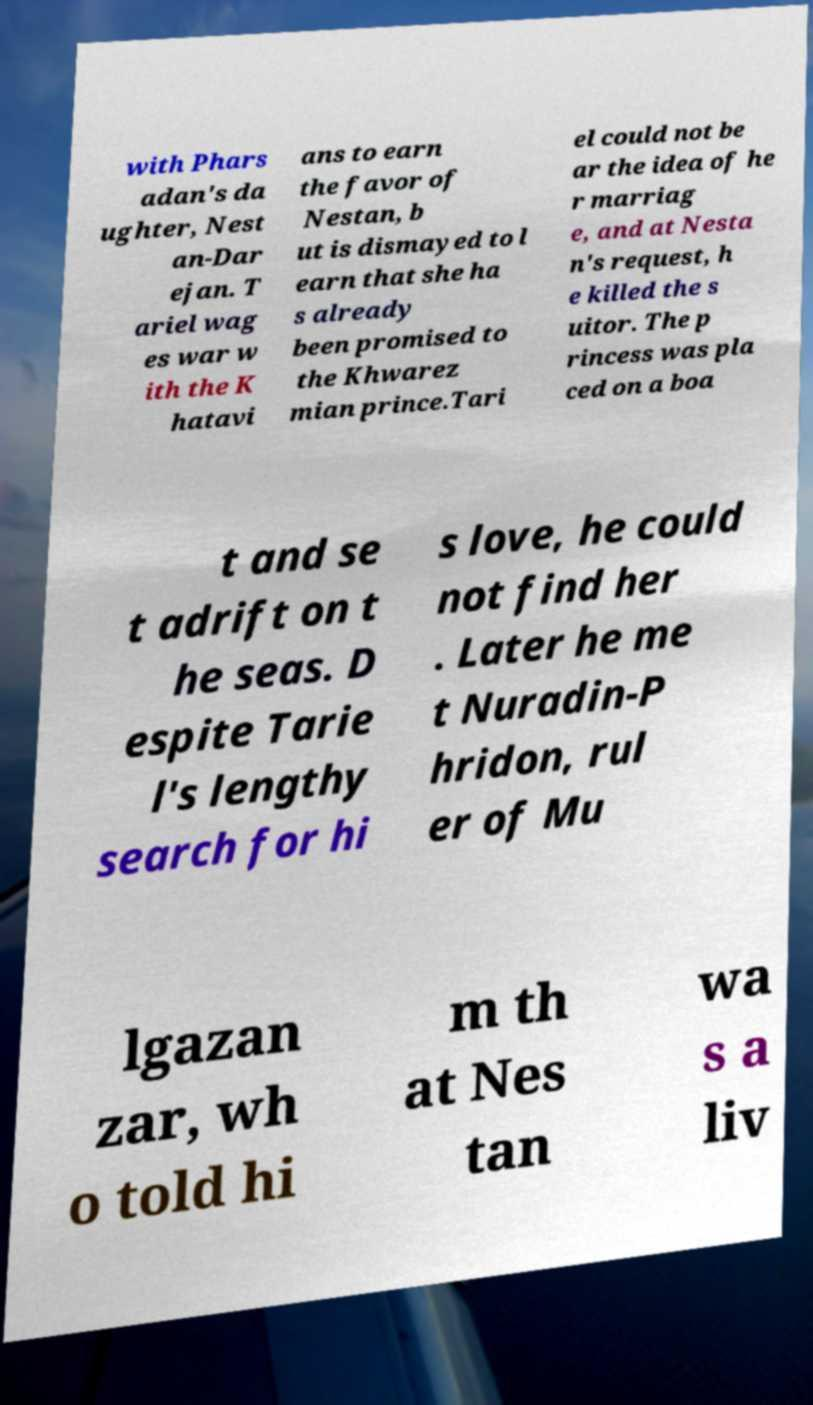Can you accurately transcribe the text from the provided image for me? with Phars adan's da ughter, Nest an-Dar ejan. T ariel wag es war w ith the K hatavi ans to earn the favor of Nestan, b ut is dismayed to l earn that she ha s already been promised to the Khwarez mian prince.Tari el could not be ar the idea of he r marriag e, and at Nesta n's request, h e killed the s uitor. The p rincess was pla ced on a boa t and se t adrift on t he seas. D espite Tarie l's lengthy search for hi s love, he could not find her . Later he me t Nuradin-P hridon, rul er of Mu lgazan zar, wh o told hi m th at Nes tan wa s a liv 